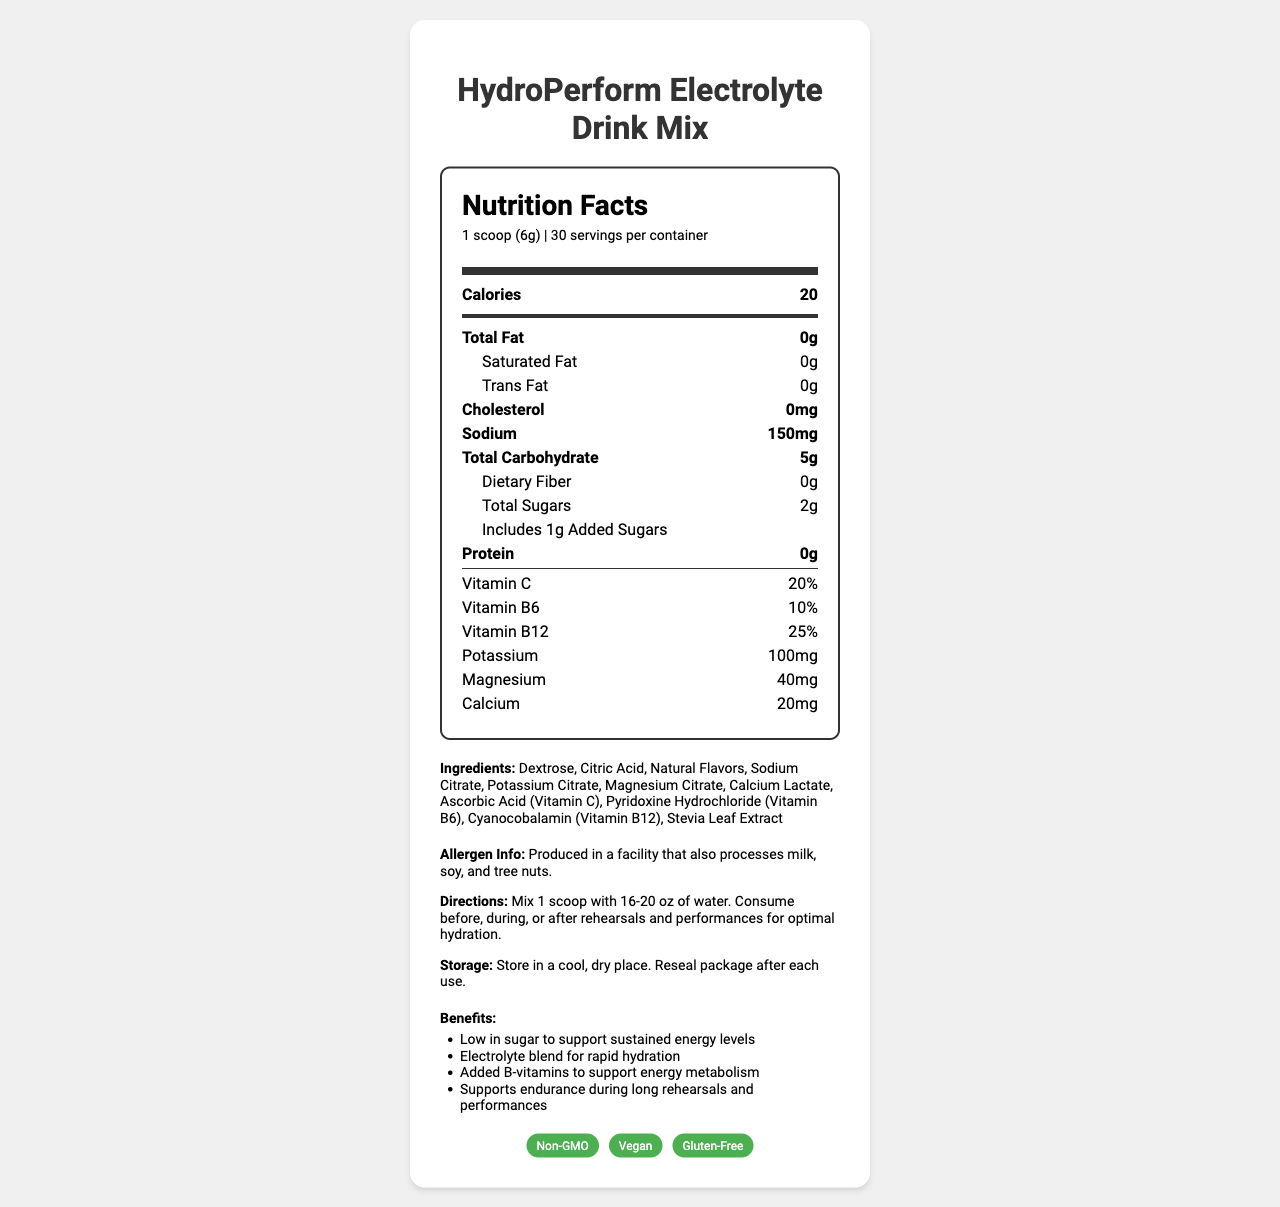what is the serving size? The serving size is mentioned at the beginning of the document as "1 scoop (6g)".
Answer: 1 scoop (6g) how many calories are in one serving of the HydroPerform Electrolyte Drink Mix? The document lists 20 calories under the main nutrients section for one serving.
Answer: 20 how much sodium does each serving provide? Sodium is listed under the main nutrients, showing a value of 150mg per serving.
Answer: 150mg what are the vitamins included in this drink mix? The document contains a section listing vitamins: Vitamin C (20%), Vitamin B6 (10%), and Vitamin B12 (25%).
Answer: Vitamin C, Vitamin B6, Vitamin B12 how much added sugar is in one serving? The document specifies that each serving includes 1g of added sugars.
Answer: 1g Which of the following certifications does the product have? A. USDA Organic B. Non-GMO C. Fair Trade Certified D. Kosher The product certifications listed in the document include Non-GMO, Vegan, and Gluten-Free, but not USDA Organic, Fair Trade Certified, or Kosher.
Answer: B. Non-GMO What is the flavor of the HydroPerform Electrolyte Drink Mix? I. Tropical Punch II. Citrus Burst III. Berry Medley The document states that the flavor of the product is Citrus Burst.
Answer: II. Citrus Burst Is the HydroPerform Electrolyte Drink Mix suitable for vegans? One of the certifications listed in the document is Vegan, indicating that the product is suitable for vegans.
Answer: Yes summarize the main idea of the document. The document provides detailed nutritional information, ingredients, directions, and benefits specific to performing artists, with certifications emphasizing its suitability for a wide audience.
Answer: The HydroPerform Electrolyte Drink Mix is a low-sugar hydration solution formulated to support performing artists by providing electrolytes, vitamins, and a small amount of calories. It is non-GMO, vegan, and gluten-free, designed to be consumed before, during, or after rehearsals and performances. how many servings are there per container? The document indicates that there are 30 servings per container.
Answer: 30 can you consume this drink mix during performances? The directions section specifies that the drink can be consumed before, during, or after rehearsals and performances.
Answer: Yes does the drink contain any dietary fiber? The total dietary fiber is listed as 0g in the document.
Answer: No what is the total carbohydrate content per serving? The total carbohydrate content per serving is listed as 5g.
Answer: 5g what storage instructions are provided for this drink mix? The document’s "storage" section specifies to store in a cool, dry place and to reseal the package after each use.
Answer: Store in a cool, dry place. Reseal package after each use. does the HydroPerform Electrolyte Drink Mix contain any milk-based ingredients? While the document states it's produced in a facility that processes milk, there is no direct information on whether milk-based ingredients are in the final product itself.
Answer: Not enough information what percentage of Vitamin C does one serving provide? The document lists that one serving provides 20% of the daily value of Vitamin C.
Answer: 20% 